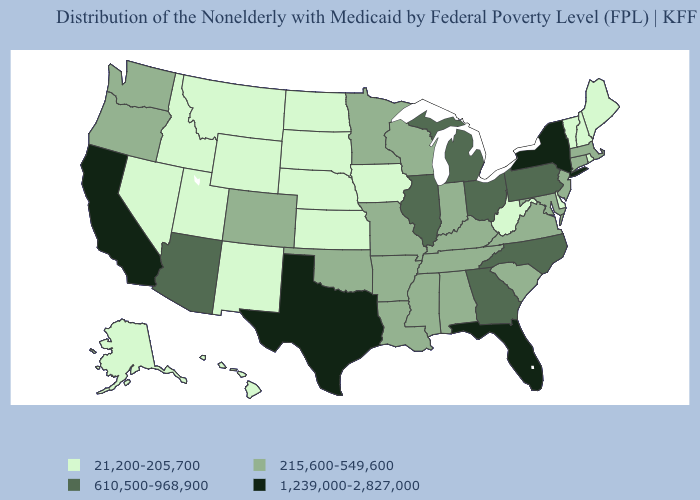Among the states that border Utah , which have the lowest value?
Be succinct. Idaho, Nevada, New Mexico, Wyoming. Name the states that have a value in the range 215,600-549,600?
Keep it brief. Alabama, Arkansas, Colorado, Connecticut, Indiana, Kentucky, Louisiana, Maryland, Massachusetts, Minnesota, Mississippi, Missouri, New Jersey, Oklahoma, Oregon, South Carolina, Tennessee, Virginia, Washington, Wisconsin. Does Florida have the highest value in the USA?
Give a very brief answer. Yes. Name the states that have a value in the range 215,600-549,600?
Be succinct. Alabama, Arkansas, Colorado, Connecticut, Indiana, Kentucky, Louisiana, Maryland, Massachusetts, Minnesota, Mississippi, Missouri, New Jersey, Oklahoma, Oregon, South Carolina, Tennessee, Virginia, Washington, Wisconsin. How many symbols are there in the legend?
Short answer required. 4. What is the value of New Mexico?
Quick response, please. 21,200-205,700. Is the legend a continuous bar?
Quick response, please. No. Does California have the highest value in the West?
Keep it brief. Yes. Which states have the highest value in the USA?
Keep it brief. California, Florida, New York, Texas. What is the value of Vermont?
Quick response, please. 21,200-205,700. How many symbols are there in the legend?
Write a very short answer. 4. What is the lowest value in states that border New Mexico?
Quick response, please. 21,200-205,700. What is the value of Texas?
Answer briefly. 1,239,000-2,827,000. Among the states that border Nebraska , which have the lowest value?
Short answer required. Iowa, Kansas, South Dakota, Wyoming. Does Texas have a higher value than California?
Answer briefly. No. 